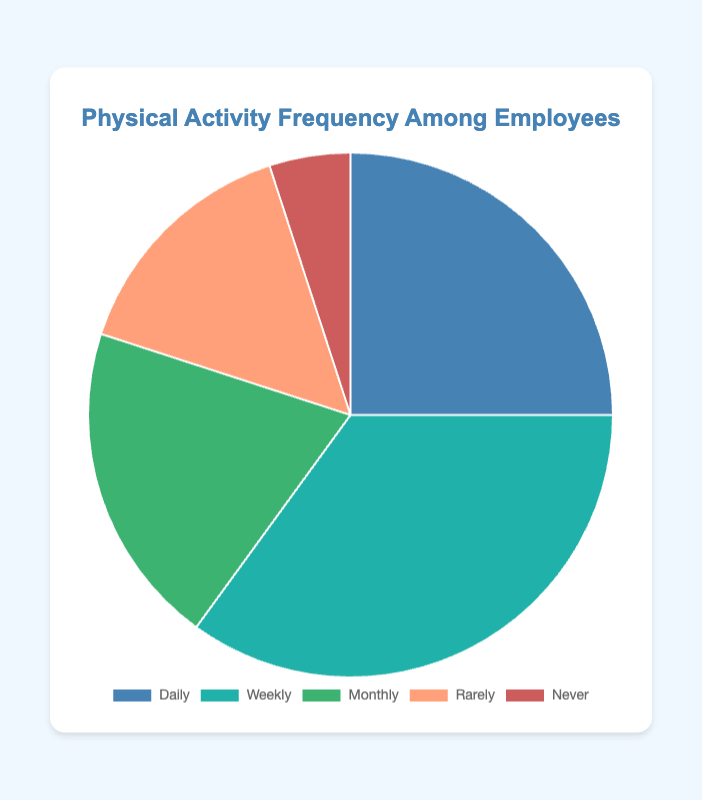What is the most common frequency of physical activity among employees? By looking at the slices of the pie chart, the largest slice corresponds to the category labeled "Weekly" with 35%. Therefore, "Weekly" is the most common frequency of physical activity among employees.
Answer: Weekly How many percent of employees exercise daily? The slice labeled "Daily" on the pie chart represents 25% of the employees.
Answer: 25% Which two categories combined make up a majority of the employees? To have a majority, the combined percentage should be more than 50%. By observing the slices, "Weekly" (35%) and "Daily" (25%) together make 60%, which is more than 50%.
Answer: Daily and Weekly What percentage of employees rarely or never exercise? To find this, we add the percentages of the "Rarely" and "Never" slices. "Rarely" is 15% and "Never" is 5%, resulting in a total of 15% + 5% = 20%.
Answer: 20% Is the number of employees who exercise monthly greater than those who rarely exercise? By comparing the sizes of the slices, the "Monthly" category represents 20%, while "Rarely" category represents 15%. Since 20% is greater than 15%, more employees exercise monthly than rarely.
Answer: Yes Which category has the smallest percentage of employees? The smallest slice corresponds to the "Never" category, which represents 5% of the employees.
Answer: Never On average, what percentage of employees exercise either daily or weekly? The average percentage can be calculated by adding the "Daily" (25%) and "Weekly" (35%) percentages and then dividing by 2: (25% + 35%) / 2 = 30%.
Answer: 30% How much larger is the percentage of employees who exercise weekly compared to those who never exercise? We subtract the percentage of the "Never" category from the "Weekly" category: 35% - 5% = 30%.
Answer: 30% What fraction of employees exercise monthly? The slice for the "Monthly" category represents 20%. As a fraction, this can be expressed as 20/100 which reduces to 1/5.
Answer: 1/5 What is the total percentage of employees that do not exercise on a daily or weekly basis? To find this, we add the percentages of "Monthly," "Rarely," and "Never" categories: 20% + 15% + 5% = 40%.
Answer: 40% 